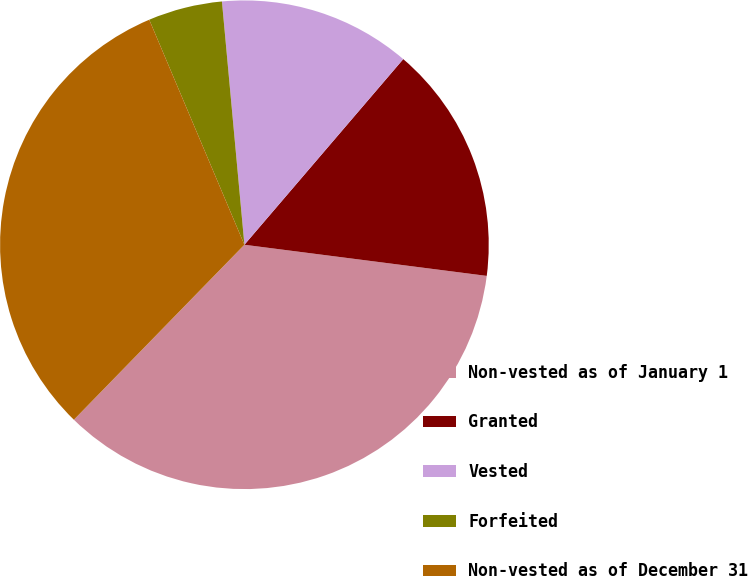Convert chart. <chart><loc_0><loc_0><loc_500><loc_500><pie_chart><fcel>Non-vested as of January 1<fcel>Granted<fcel>Vested<fcel>Forfeited<fcel>Non-vested as of December 31<nl><fcel>35.26%<fcel>15.77%<fcel>12.73%<fcel>4.9%<fcel>31.34%<nl></chart> 